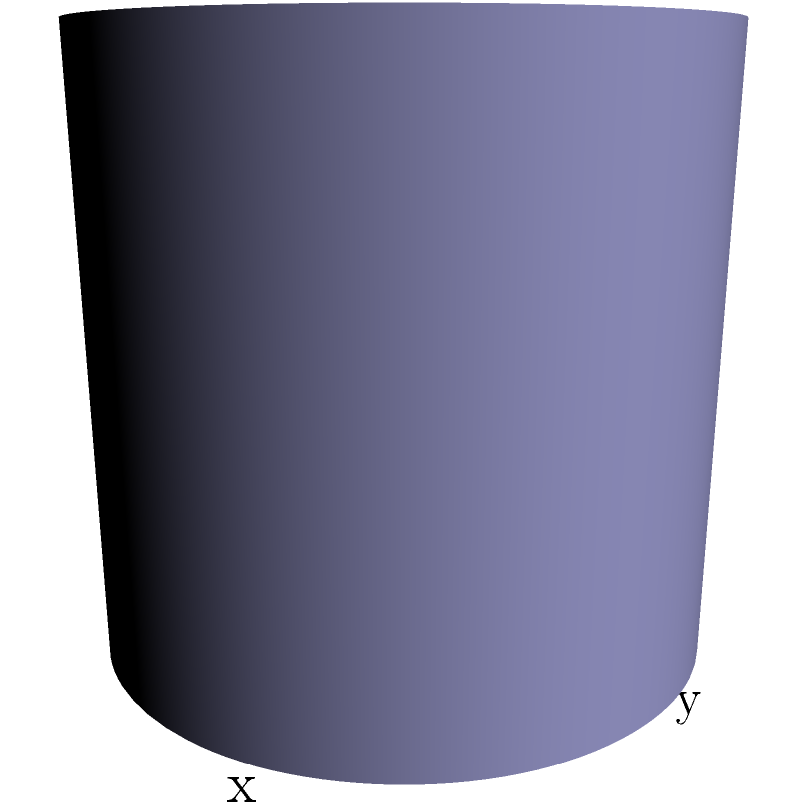As a wedding planner, you've been tasked with creating an elegant ice sculpture centerpiece for a high-profile client's reception. The sculpture is in the shape of a cylindrical column with a decorative twist. The surface of the sculpture can be described by the parametric equations:

$$x = 2\cos(u)$$
$$y = 2\sin(u)$$
$$z = v$$

where $0 \leq u \leq 2\pi$ and $0 \leq v \leq 3$. Calculate the surface area of this ice sculpture to determine the amount of ice needed and impress your client with your precision. To calculate the surface area of this parametric surface, we'll use the surface area formula for parametric surfaces:

$$A = \int\int_D \left|\frac{\partial \mathbf{r}}{\partial u} \times \frac{\partial \mathbf{r}}{\partial v}\right| \, du \, dv$$

where $\mathbf{r}(u,v) = (x(u,v), y(u,v), z(u,v))$ is the parametric representation of the surface.

Step 1: Calculate the partial derivatives
$$\frac{\partial \mathbf{r}}{\partial u} = (-2\sin(u), 2\cos(u), 0)$$
$$\frac{\partial \mathbf{r}}{\partial v} = (0, 0, 1)$$

Step 2: Calculate the cross product
$$\frac{\partial \mathbf{r}}{\partial u} \times \frac{\partial \mathbf{r}}{\partial v} = (2\cos(u), 2\sin(u), 0)$$

Step 3: Calculate the magnitude of the cross product
$$\left|\frac{\partial \mathbf{r}}{\partial u} \times \frac{\partial \mathbf{r}}{\partial v}\right| = \sqrt{(2\cos(u))^2 + (2\sin(u))^2 + 0^2} = 2$$

Step 4: Set up the double integral
$$A = \int_0^3 \int_0^{2\pi} 2 \, du \, dv$$

Step 5: Evaluate the integral
$$A = 2 \int_0^3 \int_0^{2\pi} \, du \, dv = 2 \cdot 3 \cdot 2\pi = 12\pi$$

Therefore, the surface area of the ice sculpture is $12\pi$ square units.
Answer: $12\pi$ square units 